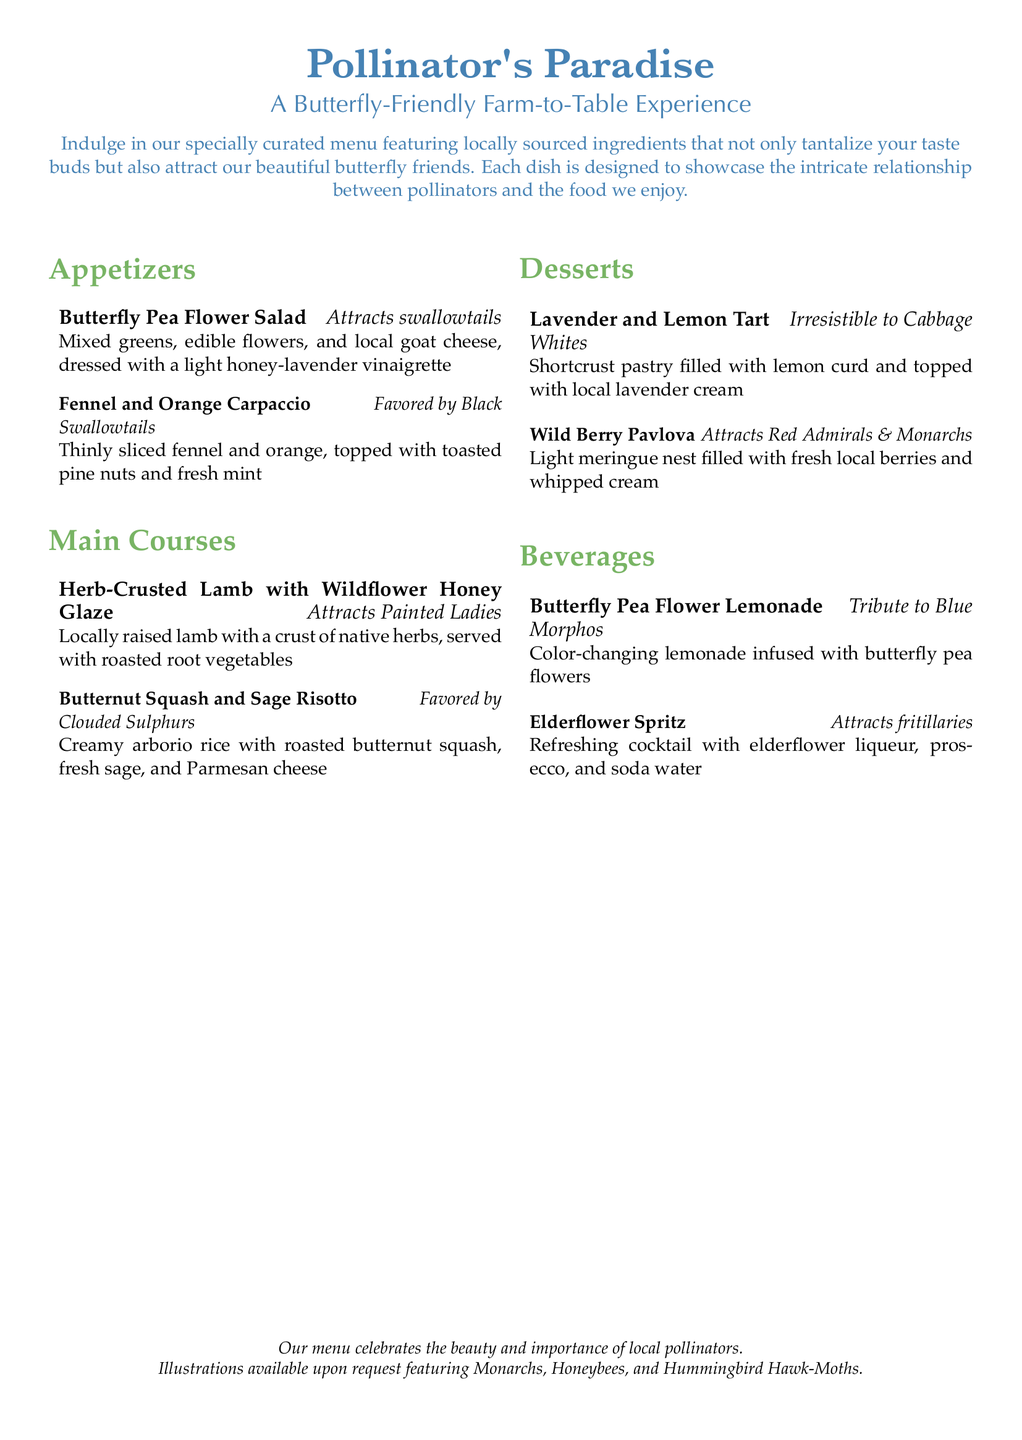What is the name of the restaurant? The name of the restaurant is "Pollinator's Paradise."
Answer: Pollinator's Paradise What is the theme of the menu? The theme of the menu highlights locally sourced ingredients that attract butterflies.
Answer: Butterfly-Friendly Farm-to-Table Experience Which appetizer attracts swallowtails? The appetizer that attracts swallowtails is the Butterfly Pea Flower Salad.
Answer: Butterfly Pea Flower Salad What dessert is favored by Clouded Sulphurs? The dessert favored by Clouded Sulphurs is the Butternut Squash and Sage Risotto.
Answer: Butternut Squash and Sage Risotto How many main courses are listed on the menu? The menu lists two main courses under the main courses section.
Answer: 2 What beverage is a tribute to Blue Morphos? The beverage that is a tribute to Blue Morphos is Butterfly Pea Flower Lemonade.
Answer: Butterfly Pea Flower Lemonade Which dessert attracts Red Admirals and Monarchs? The dessert that attracts Red Admirals and Monarchs is Wild Berry Pavlova.
Answer: Wild Berry Pavlova What color is associated with the main title? The color associated with the main title is butterfly blue.
Answer: butterfly blue What type of illustrations are available upon request? The type of illustrations available upon request features Monarchs, Honeybees, and Hummingbird Hawk-Moths.
Answer: Monarchs, Honeybees, and Hummingbird Hawk-Moths 